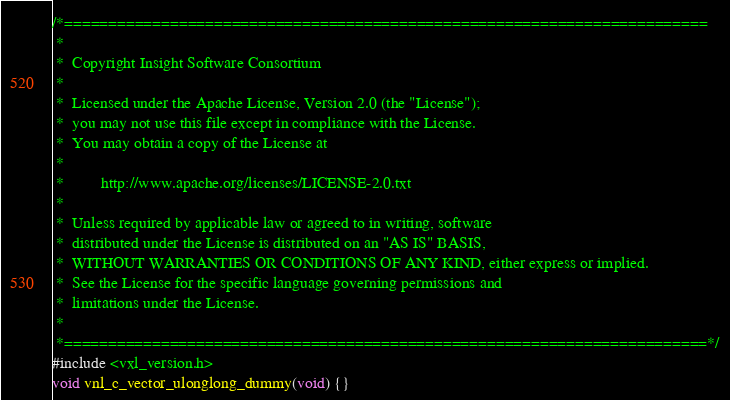<code> <loc_0><loc_0><loc_500><loc_500><_C++_>/*=========================================================================
 *
 *  Copyright Insight Software Consortium
 *
 *  Licensed under the Apache License, Version 2.0 (the "License");
 *  you may not use this file except in compliance with the License.
 *  You may obtain a copy of the License at
 *
 *         http://www.apache.org/licenses/LICENSE-2.0.txt
 *
 *  Unless required by applicable law or agreed to in writing, software
 *  distributed under the License is distributed on an "AS IS" BASIS,
 *  WITHOUT WARRANTIES OR CONDITIONS OF ANY KIND, either express or implied.
 *  See the License for the specific language governing permissions and
 *  limitations under the License.
 *
 *=========================================================================*/
#include <vxl_version.h>
void vnl_c_vector_ulonglong_dummy(void) {}
</code> 